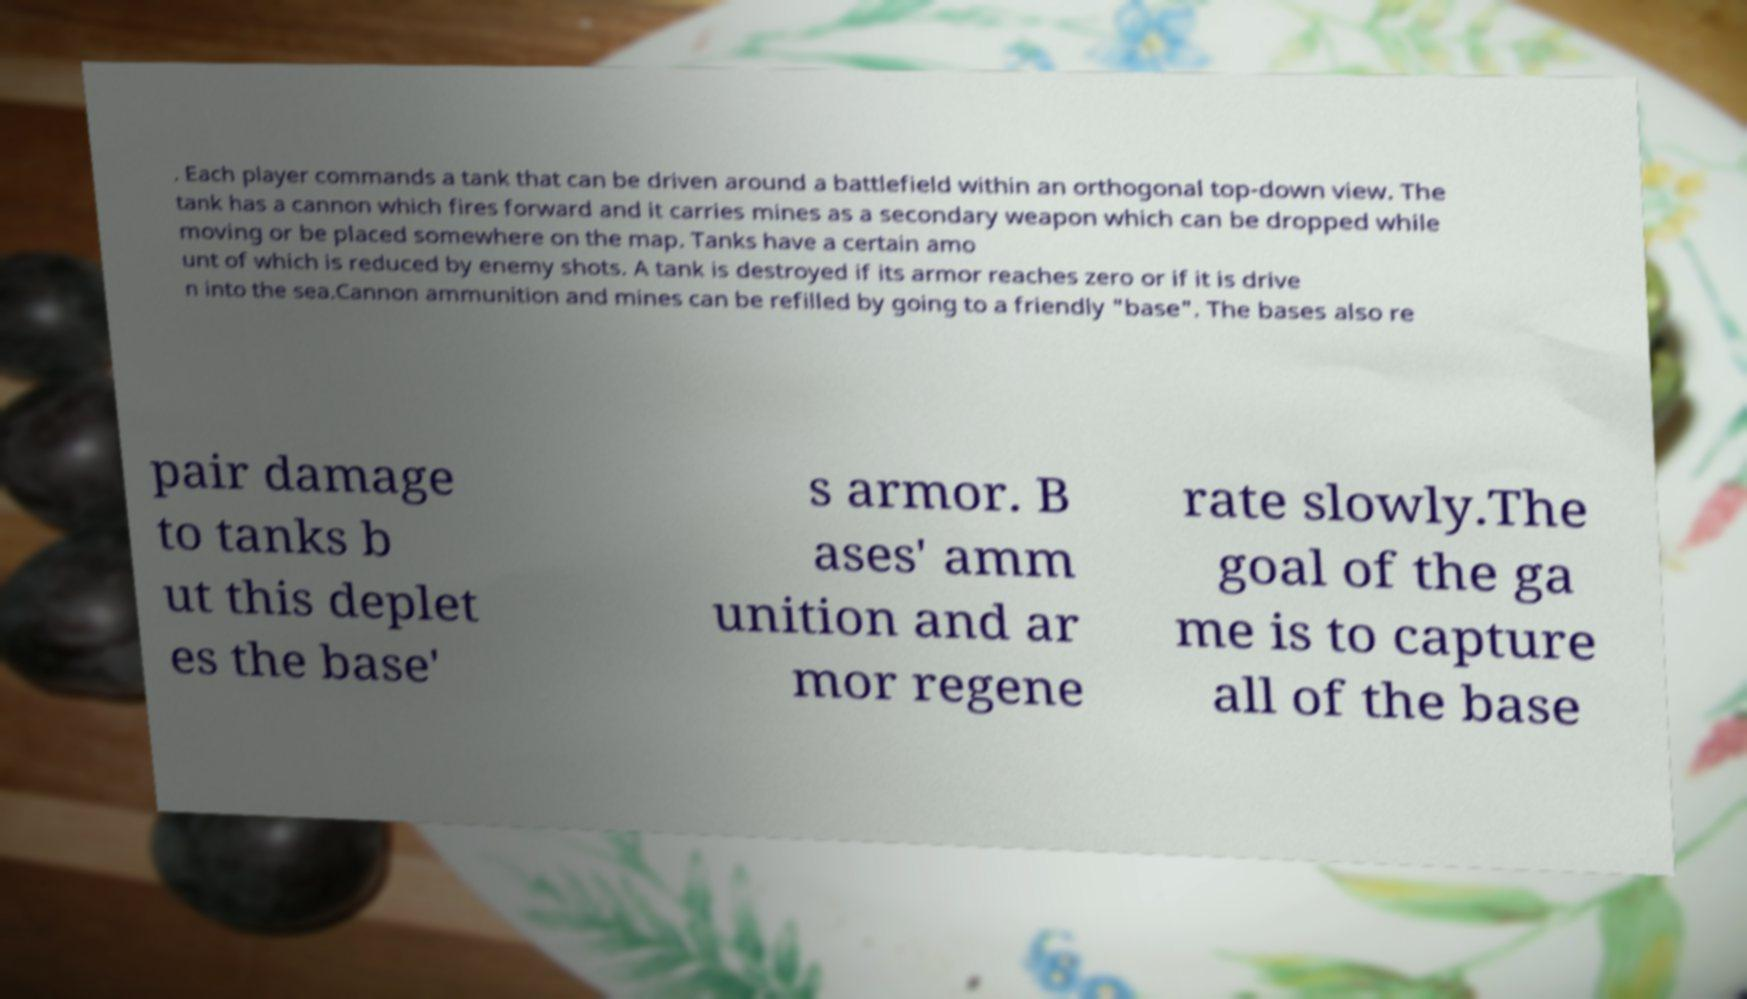I need the written content from this picture converted into text. Can you do that? . Each player commands a tank that can be driven around a battlefield within an orthogonal top-down view. The tank has a cannon which fires forward and it carries mines as a secondary weapon which can be dropped while moving or be placed somewhere on the map. Tanks have a certain amo unt of which is reduced by enemy shots. A tank is destroyed if its armor reaches zero or if it is drive n into the sea.Cannon ammunition and mines can be refilled by going to a friendly "base". The bases also re pair damage to tanks b ut this deplet es the base' s armor. B ases' amm unition and ar mor regene rate slowly.The goal of the ga me is to capture all of the base 